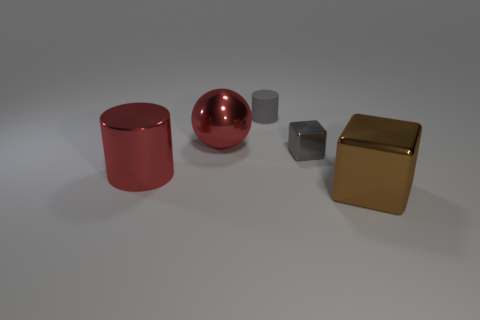The metallic ball that is the same color as the big metallic cylinder is what size?
Keep it short and to the point. Large. Do the tiny gray block and the small cylinder have the same material?
Offer a very short reply. No. Is there anything else that is made of the same material as the tiny gray cylinder?
Offer a terse response. No. How many big blue cubes are there?
Keep it short and to the point. 0. How many shiny spheres are the same size as the brown block?
Your response must be concise. 1. What is the material of the small cylinder?
Keep it short and to the point. Rubber. There is a tiny matte object; is it the same color as the metallic block behind the big brown metallic object?
Provide a succinct answer. Yes. There is a metallic object that is in front of the gray cube and behind the brown object; what size is it?
Provide a short and direct response. Large. There is a large brown object that is made of the same material as the tiny gray block; what is its shape?
Ensure brevity in your answer.  Cube. Are the brown object and the cube that is behind the big shiny cylinder made of the same material?
Give a very brief answer. Yes. 